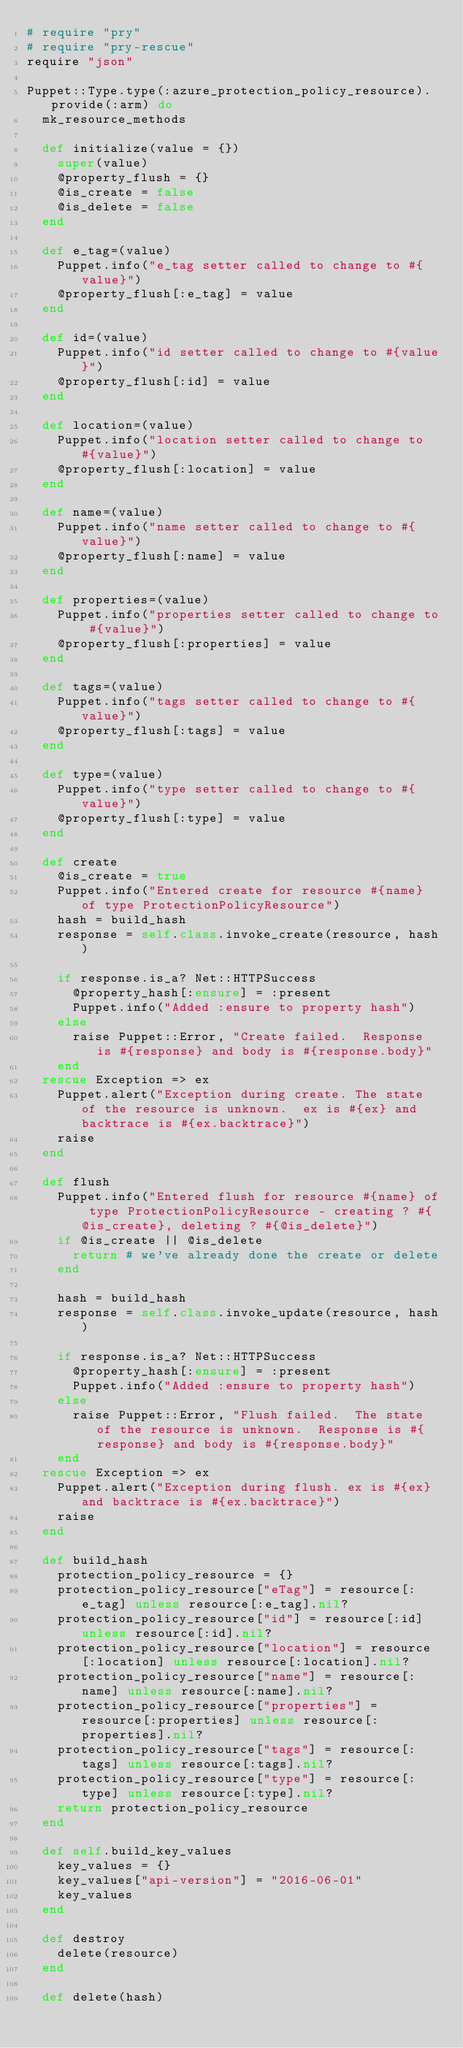Convert code to text. <code><loc_0><loc_0><loc_500><loc_500><_Ruby_># require "pry"
# require "pry-rescue"
require "json"

Puppet::Type.type(:azure_protection_policy_resource).provide(:arm) do
  mk_resource_methods

  def initialize(value = {})
    super(value)
    @property_flush = {}
    @is_create = false
    @is_delete = false
  end

  def e_tag=(value)
    Puppet.info("e_tag setter called to change to #{value}")
    @property_flush[:e_tag] = value
  end

  def id=(value)
    Puppet.info("id setter called to change to #{value}")
    @property_flush[:id] = value
  end

  def location=(value)
    Puppet.info("location setter called to change to #{value}")
    @property_flush[:location] = value
  end

  def name=(value)
    Puppet.info("name setter called to change to #{value}")
    @property_flush[:name] = value
  end

  def properties=(value)
    Puppet.info("properties setter called to change to #{value}")
    @property_flush[:properties] = value
  end

  def tags=(value)
    Puppet.info("tags setter called to change to #{value}")
    @property_flush[:tags] = value
  end

  def type=(value)
    Puppet.info("type setter called to change to #{value}")
    @property_flush[:type] = value
  end

  def create
    @is_create = true
    Puppet.info("Entered create for resource #{name} of type ProtectionPolicyResource")
    hash = build_hash
    response = self.class.invoke_create(resource, hash)

    if response.is_a? Net::HTTPSuccess
      @property_hash[:ensure] = :present
      Puppet.info("Added :ensure to property hash")
    else
      raise Puppet::Error, "Create failed.  Response is #{response} and body is #{response.body}"
    end
  rescue Exception => ex
    Puppet.alert("Exception during create. The state of the resource is unknown.  ex is #{ex} and backtrace is #{ex.backtrace}")
    raise
  end

  def flush
    Puppet.info("Entered flush for resource #{name} of type ProtectionPolicyResource - creating ? #{@is_create}, deleting ? #{@is_delete}")
    if @is_create || @is_delete
      return # we've already done the create or delete
    end

    hash = build_hash
    response = self.class.invoke_update(resource, hash)

    if response.is_a? Net::HTTPSuccess
      @property_hash[:ensure] = :present
      Puppet.info("Added :ensure to property hash")
    else
      raise Puppet::Error, "Flush failed.  The state of the resource is unknown.  Response is #{response} and body is #{response.body}"
    end
  rescue Exception => ex
    Puppet.alert("Exception during flush. ex is #{ex} and backtrace is #{ex.backtrace}")
    raise
  end

  def build_hash
    protection_policy_resource = {}
    protection_policy_resource["eTag"] = resource[:e_tag] unless resource[:e_tag].nil?
    protection_policy_resource["id"] = resource[:id] unless resource[:id].nil?
    protection_policy_resource["location"] = resource[:location] unless resource[:location].nil?
    protection_policy_resource["name"] = resource[:name] unless resource[:name].nil?
    protection_policy_resource["properties"] = resource[:properties] unless resource[:properties].nil?
    protection_policy_resource["tags"] = resource[:tags] unless resource[:tags].nil?
    protection_policy_resource["type"] = resource[:type] unless resource[:type].nil?
    return protection_policy_resource
  end

  def self.build_key_values
    key_values = {}
    key_values["api-version"] = "2016-06-01"
    key_values
  end

  def destroy
    delete(resource)
  end

  def delete(hash)</code> 